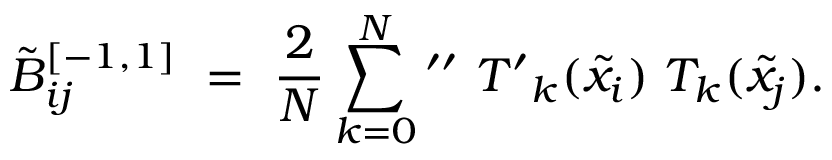Convert formula to latex. <formula><loc_0><loc_0><loc_500><loc_500>\tilde { B } _ { i j } ^ { [ - 1 , 1 ] } \ = \ \frac { 2 } { N } \sum _ { k = 0 } ^ { N ^ { \prime \prime } \ { T ^ { \prime } } _ { k } ( \tilde { x } _ { i } ) \ T _ { k } ( \tilde { x } _ { j } ) .</formula> 